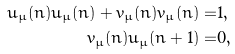<formula> <loc_0><loc_0><loc_500><loc_500>\bar { u } _ { \mu } ( n ) u _ { \mu } ( n ) + \bar { v } _ { \mu } ( n ) v _ { \mu } ( n ) = & 1 , \\ \bar { v } _ { \mu } ( n ) u _ { \mu } ( n + 1 ) = & 0 ,</formula> 